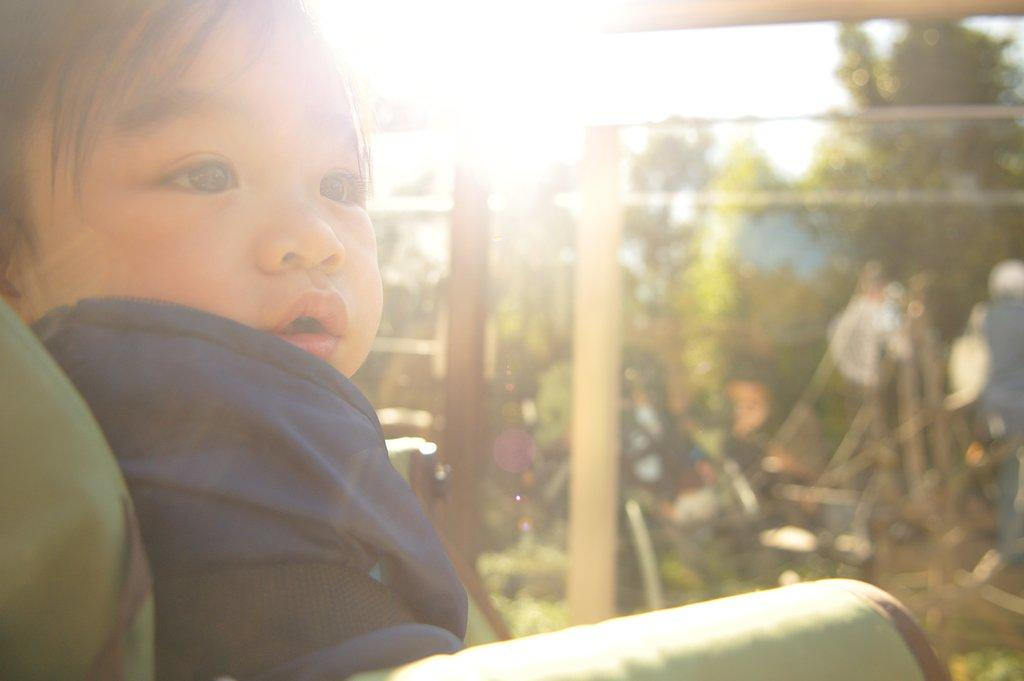What is the main subject of the image? The main subject of the image is a baby. What is the baby wearing? The baby is wearing a violet dress. Where is the baby sitting? The baby is sitting on a chair. What can be seen in the background of the image? There are two poles near plants, trees, and the sky visible in the background of the image. What type of test is the baby taking in the image? There is no test present in the image; it features a baby sitting on a chair wearing a violet dress. 